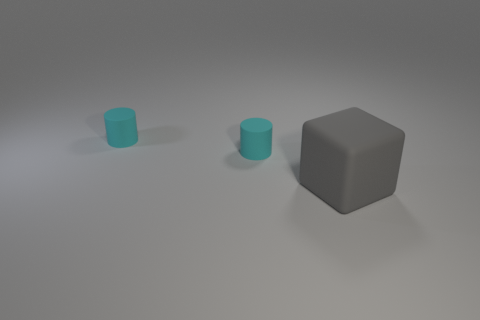Subtract all purple cylinders. How many purple blocks are left? 0 Add 2 big objects. How many objects exist? 5 Subtract all blocks. How many objects are left? 2 Subtract all blue cubes. Subtract all blue balls. How many cubes are left? 1 Subtract all tiny rubber cylinders. Subtract all large matte blocks. How many objects are left? 0 Add 1 small cylinders. How many small cylinders are left? 3 Add 2 small cyan things. How many small cyan things exist? 4 Subtract 0 brown cubes. How many objects are left? 3 